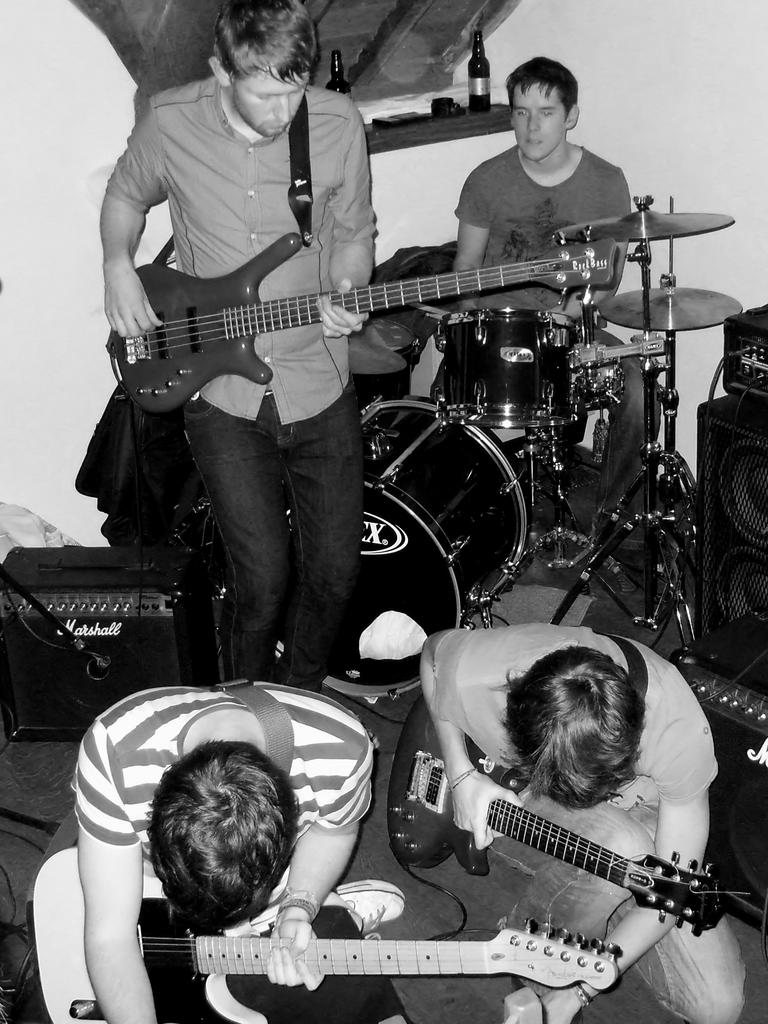What is the color scheme of the image? The image is black and white. What is happening in the image? There is a group of people in the image. What are the people doing in the image? The people are holding music instruments. What can be seen in the background of the image? There is a wall in the background of the image. Can you tell me how many carpenters are present in the image? There is no carpenter present in the image; it features a group of people holding music instruments. What type of train can be seen in the background of the image? There is no train present in the image; the background features a wall. 